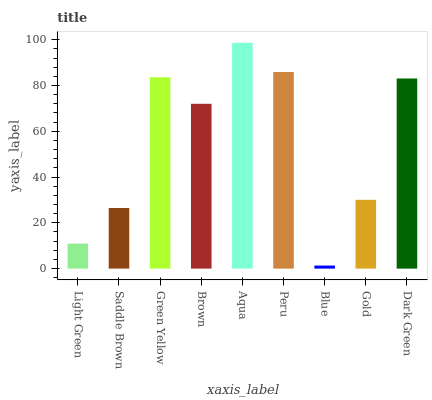Is Saddle Brown the minimum?
Answer yes or no. No. Is Saddle Brown the maximum?
Answer yes or no. No. Is Saddle Brown greater than Light Green?
Answer yes or no. Yes. Is Light Green less than Saddle Brown?
Answer yes or no. Yes. Is Light Green greater than Saddle Brown?
Answer yes or no. No. Is Saddle Brown less than Light Green?
Answer yes or no. No. Is Brown the high median?
Answer yes or no. Yes. Is Brown the low median?
Answer yes or no. Yes. Is Gold the high median?
Answer yes or no. No. Is Aqua the low median?
Answer yes or no. No. 